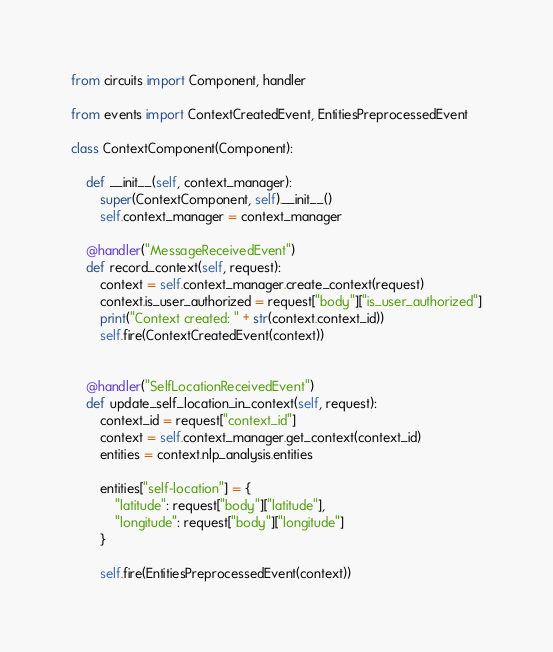Convert code to text. <code><loc_0><loc_0><loc_500><loc_500><_Python_>from circuits import Component, handler

from events import ContextCreatedEvent, EntitiesPreprocessedEvent

class ContextComponent(Component):

    def __init__(self, context_manager):
        super(ContextComponent, self).__init__()
        self.context_manager = context_manager

    @handler("MessageReceivedEvent")
    def record_context(self, request):
        context = self.context_manager.create_context(request)
        context.is_user_authorized = request["body"]["is_user_authorized"]
        print("Context created: " + str(context.context_id))
        self.fire(ContextCreatedEvent(context))


    @handler("SelfLocationReceivedEvent")
    def update_self_location_in_context(self, request):
        context_id = request["context_id"]
        context = self.context_manager.get_context(context_id)
        entities = context.nlp_analysis.entities

        entities["self-location"] = {
            "latitude": request["body"]["latitude"],
            "longitude": request["body"]["longitude"]
        }

        self.fire(EntitiesPreprocessedEvent(context))
</code> 